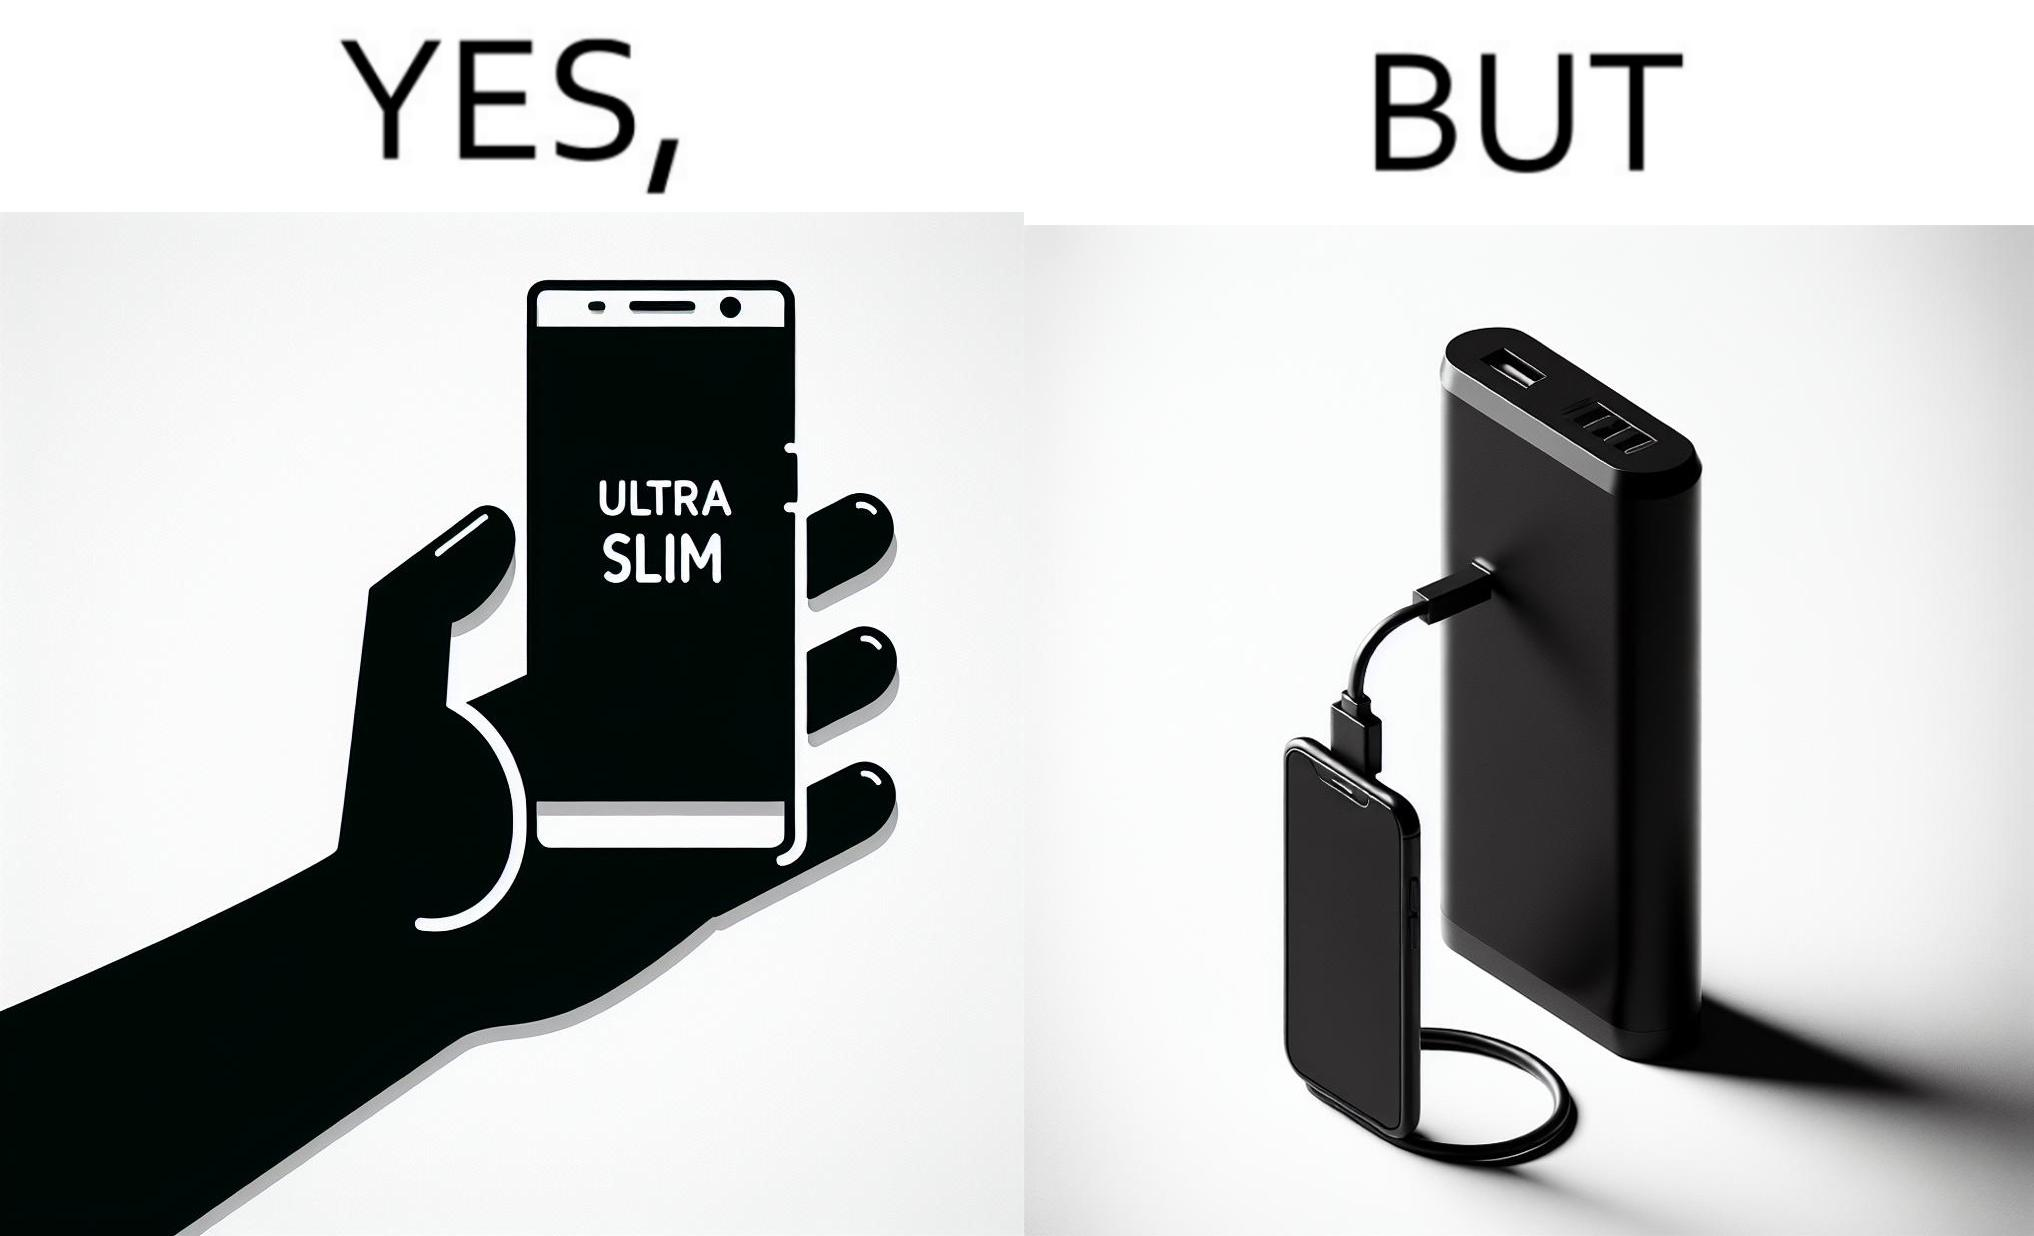Is this image satirical or non-satirical? Yes, this image is satirical. 